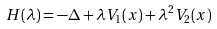Convert formula to latex. <formula><loc_0><loc_0><loc_500><loc_500>H ( \lambda ) = - \Delta + \lambda V _ { 1 } ( x ) + \lambda ^ { 2 } V _ { 2 } ( x )</formula> 